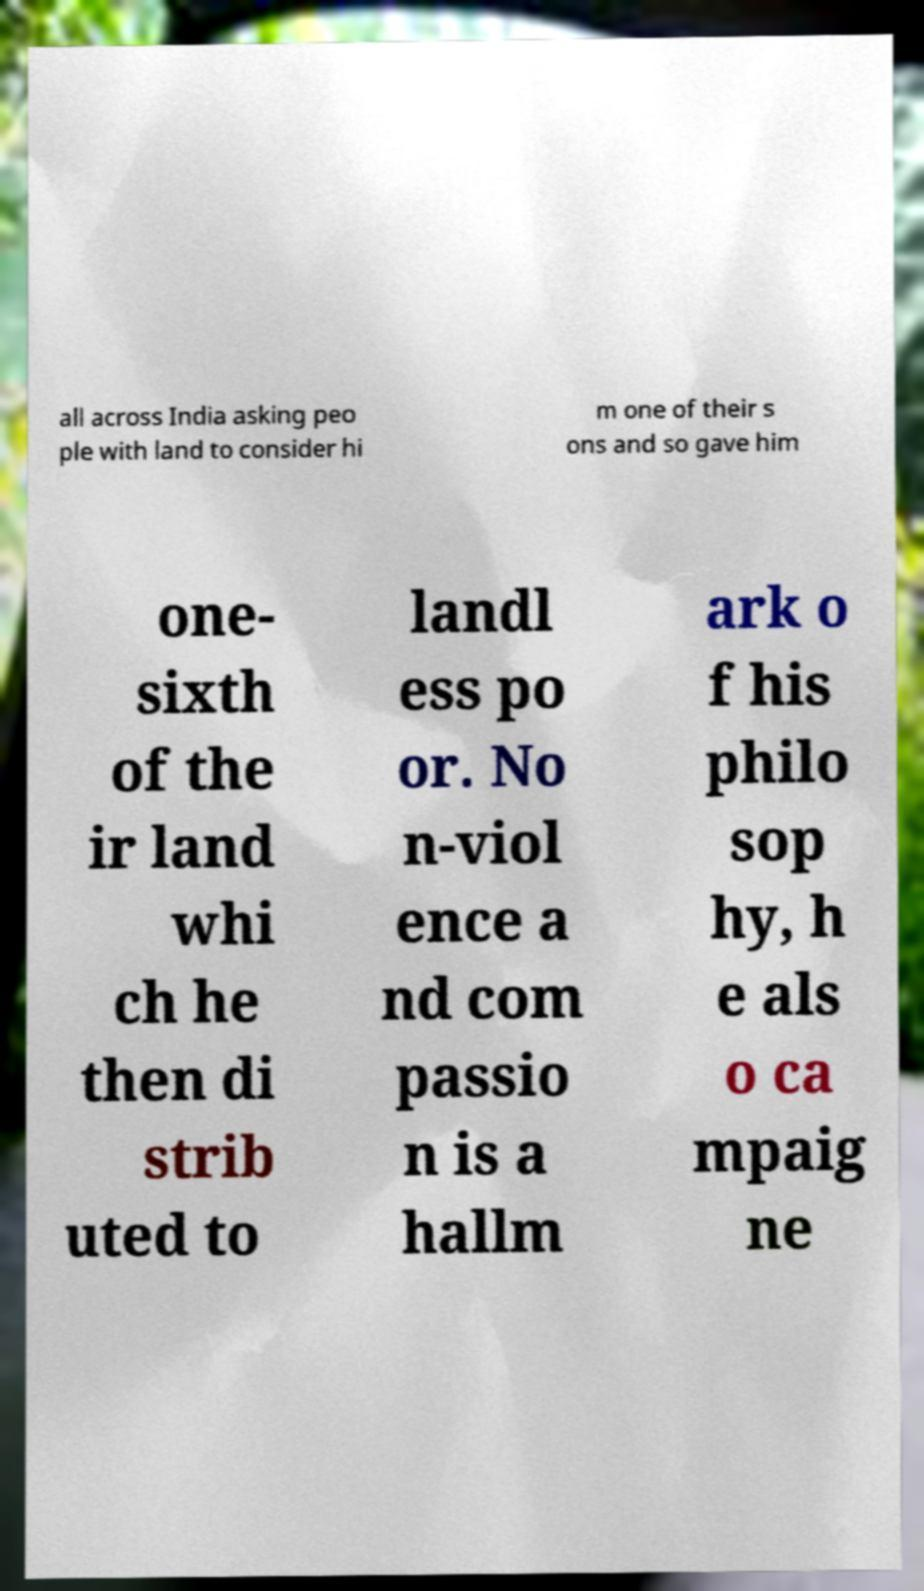Please identify and transcribe the text found in this image. all across India asking peo ple with land to consider hi m one of their s ons and so gave him one- sixth of the ir land whi ch he then di strib uted to landl ess po or. No n-viol ence a nd com passio n is a hallm ark o f his philo sop hy, h e als o ca mpaig ne 